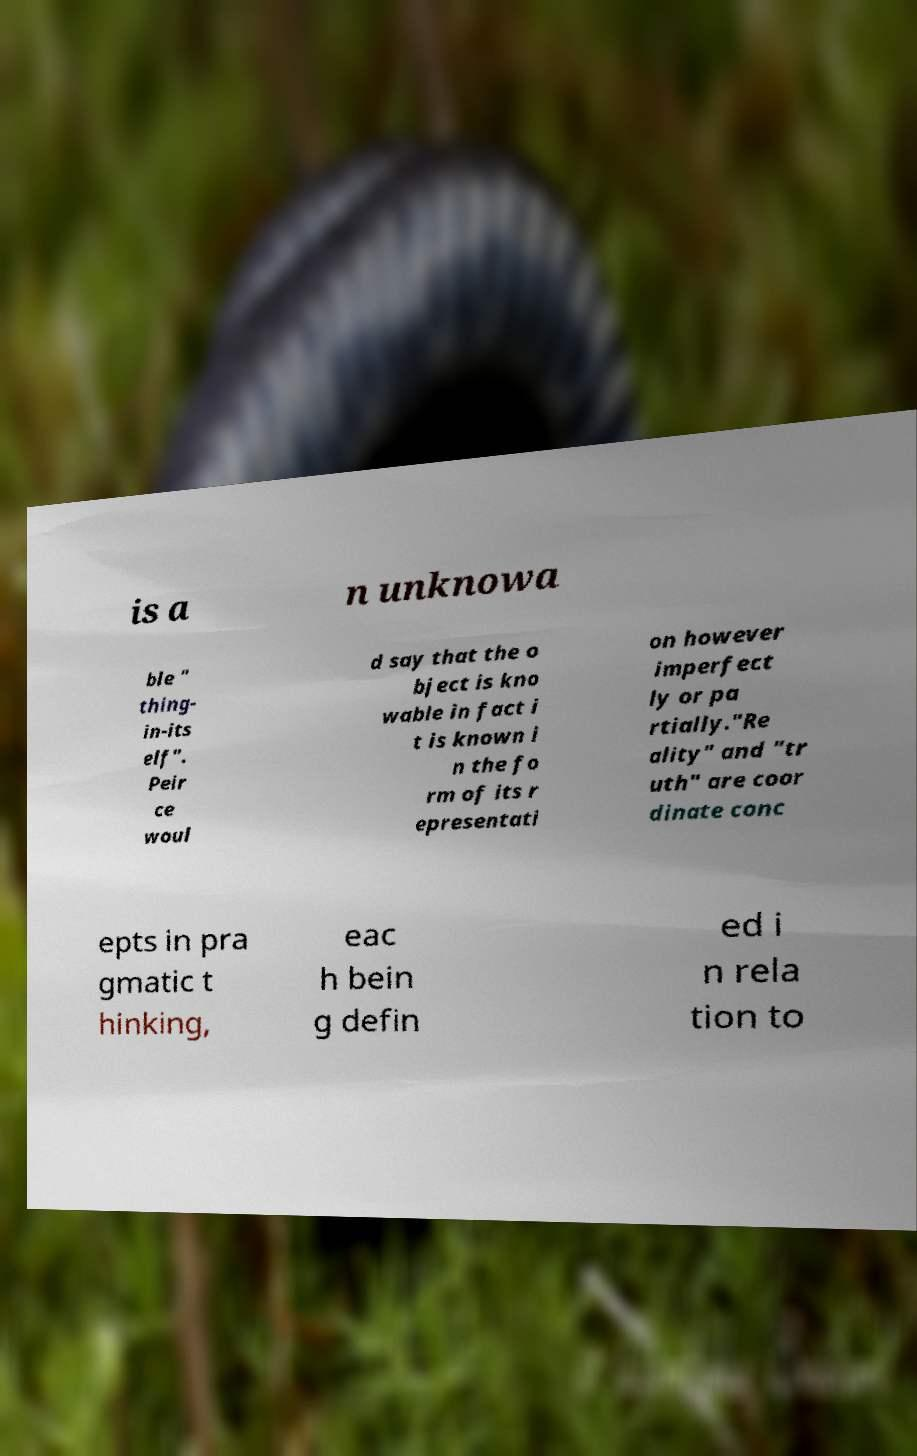Please read and relay the text visible in this image. What does it say? is a n unknowa ble " thing- in-its elf". Peir ce woul d say that the o bject is kno wable in fact i t is known i n the fo rm of its r epresentati on however imperfect ly or pa rtially."Re ality" and "tr uth" are coor dinate conc epts in pra gmatic t hinking, eac h bein g defin ed i n rela tion to 